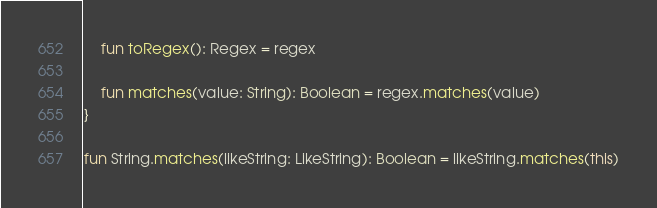<code> <loc_0><loc_0><loc_500><loc_500><_Kotlin_>
    fun toRegex(): Regex = regex

    fun matches(value: String): Boolean = regex.matches(value)
}

fun String.matches(likeString: LikeString): Boolean = likeString.matches(this)</code> 